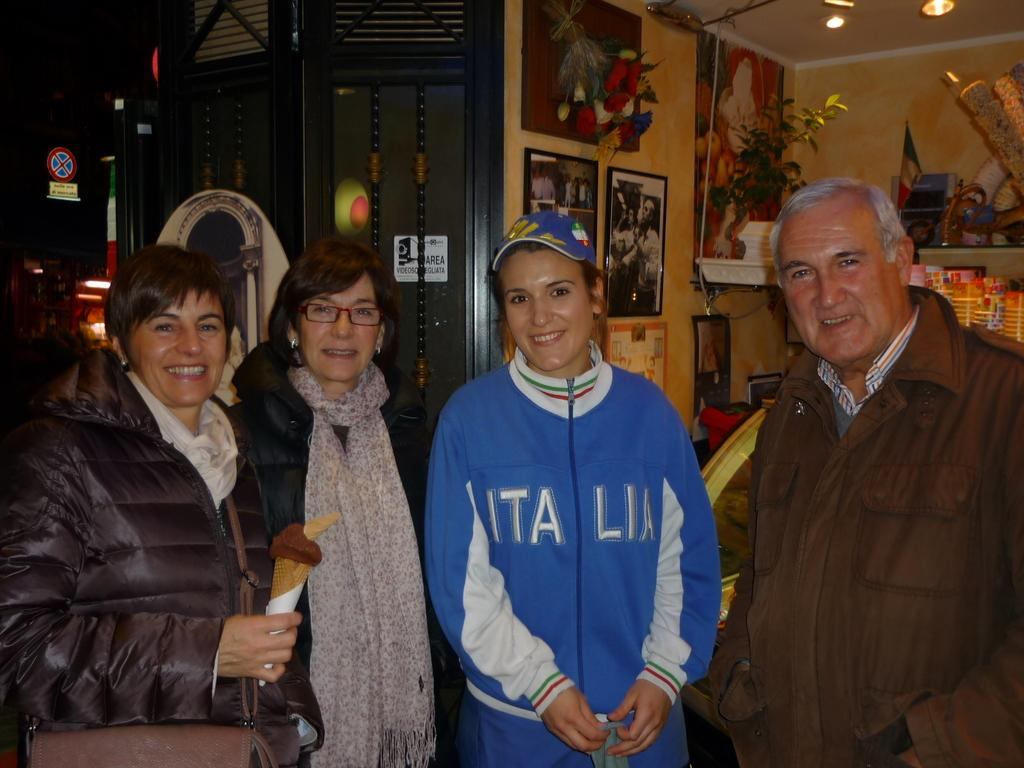<image>
Relay a brief, clear account of the picture shown. Four people are posing in a shop and one of the women is wearing a jacket that says Italia. 